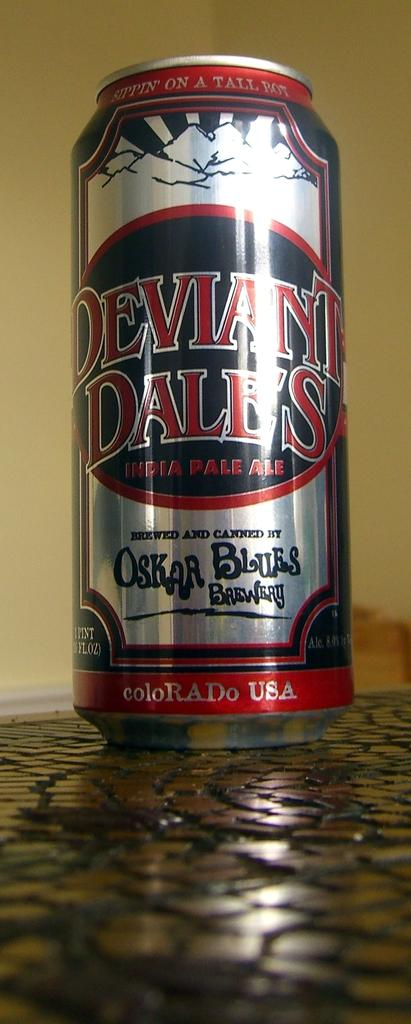<image>
Write a terse but informative summary of the picture. Deviant Dales India Pale Ale made in Colorado USA. 